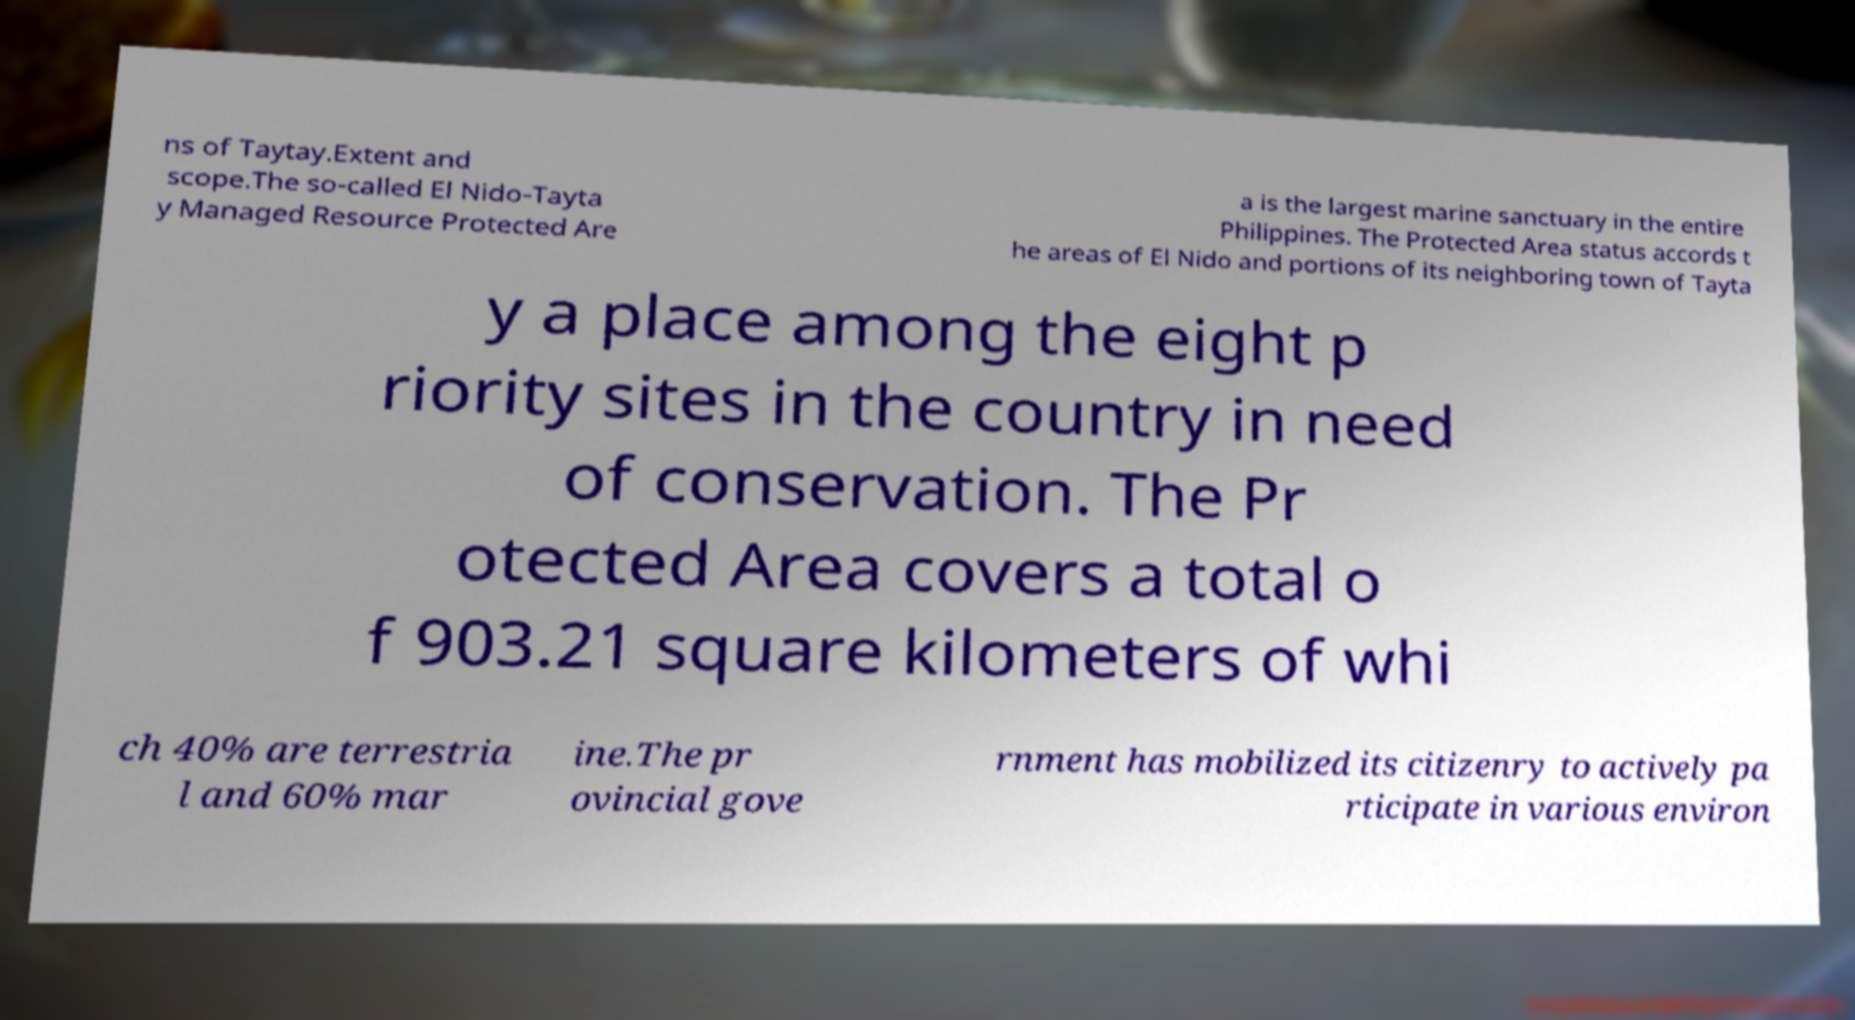Could you extract and type out the text from this image? ns of Taytay.Extent and scope.The so-called El Nido-Tayta y Managed Resource Protected Are a is the largest marine sanctuary in the entire Philippines. The Protected Area status accords t he areas of El Nido and portions of its neighboring town of Tayta y a place among the eight p riority sites in the country in need of conservation. The Pr otected Area covers a total o f 903.21 square kilometers of whi ch 40% are terrestria l and 60% mar ine.The pr ovincial gove rnment has mobilized its citizenry to actively pa rticipate in various environ 